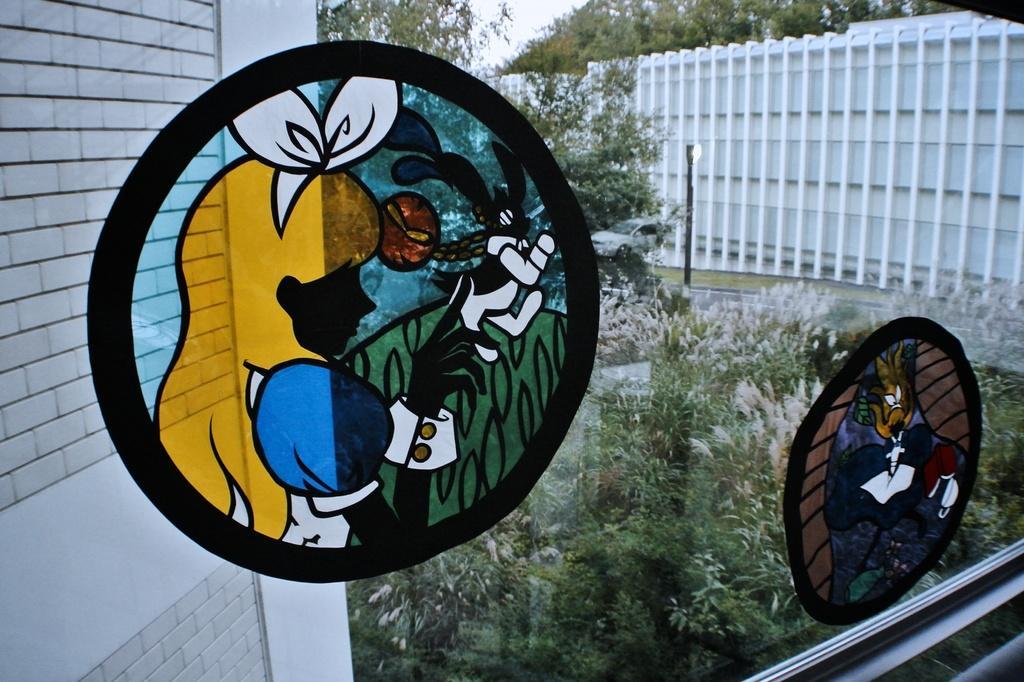Describe this image in one or two sentences. In this picture we can see a glass with the painting. Behind the glass there are trees, building and a sky. 